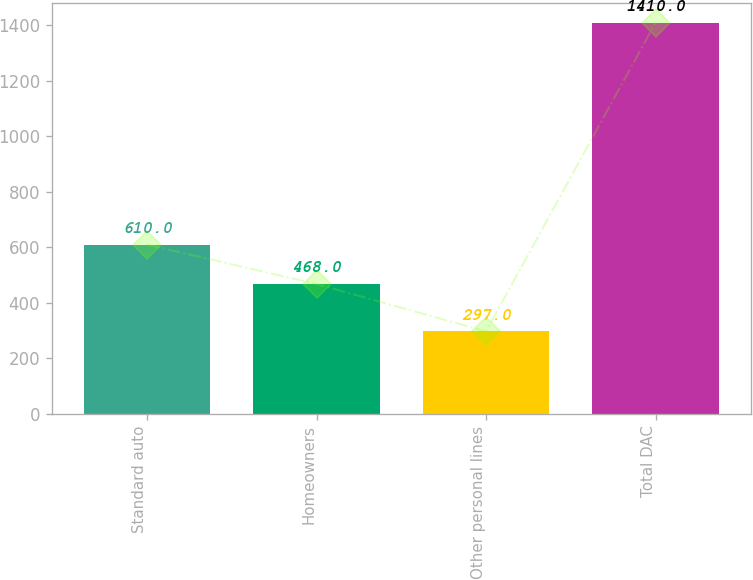Convert chart to OTSL. <chart><loc_0><loc_0><loc_500><loc_500><bar_chart><fcel>Standard auto<fcel>Homeowners<fcel>Other personal lines<fcel>Total DAC<nl><fcel>610<fcel>468<fcel>297<fcel>1410<nl></chart> 